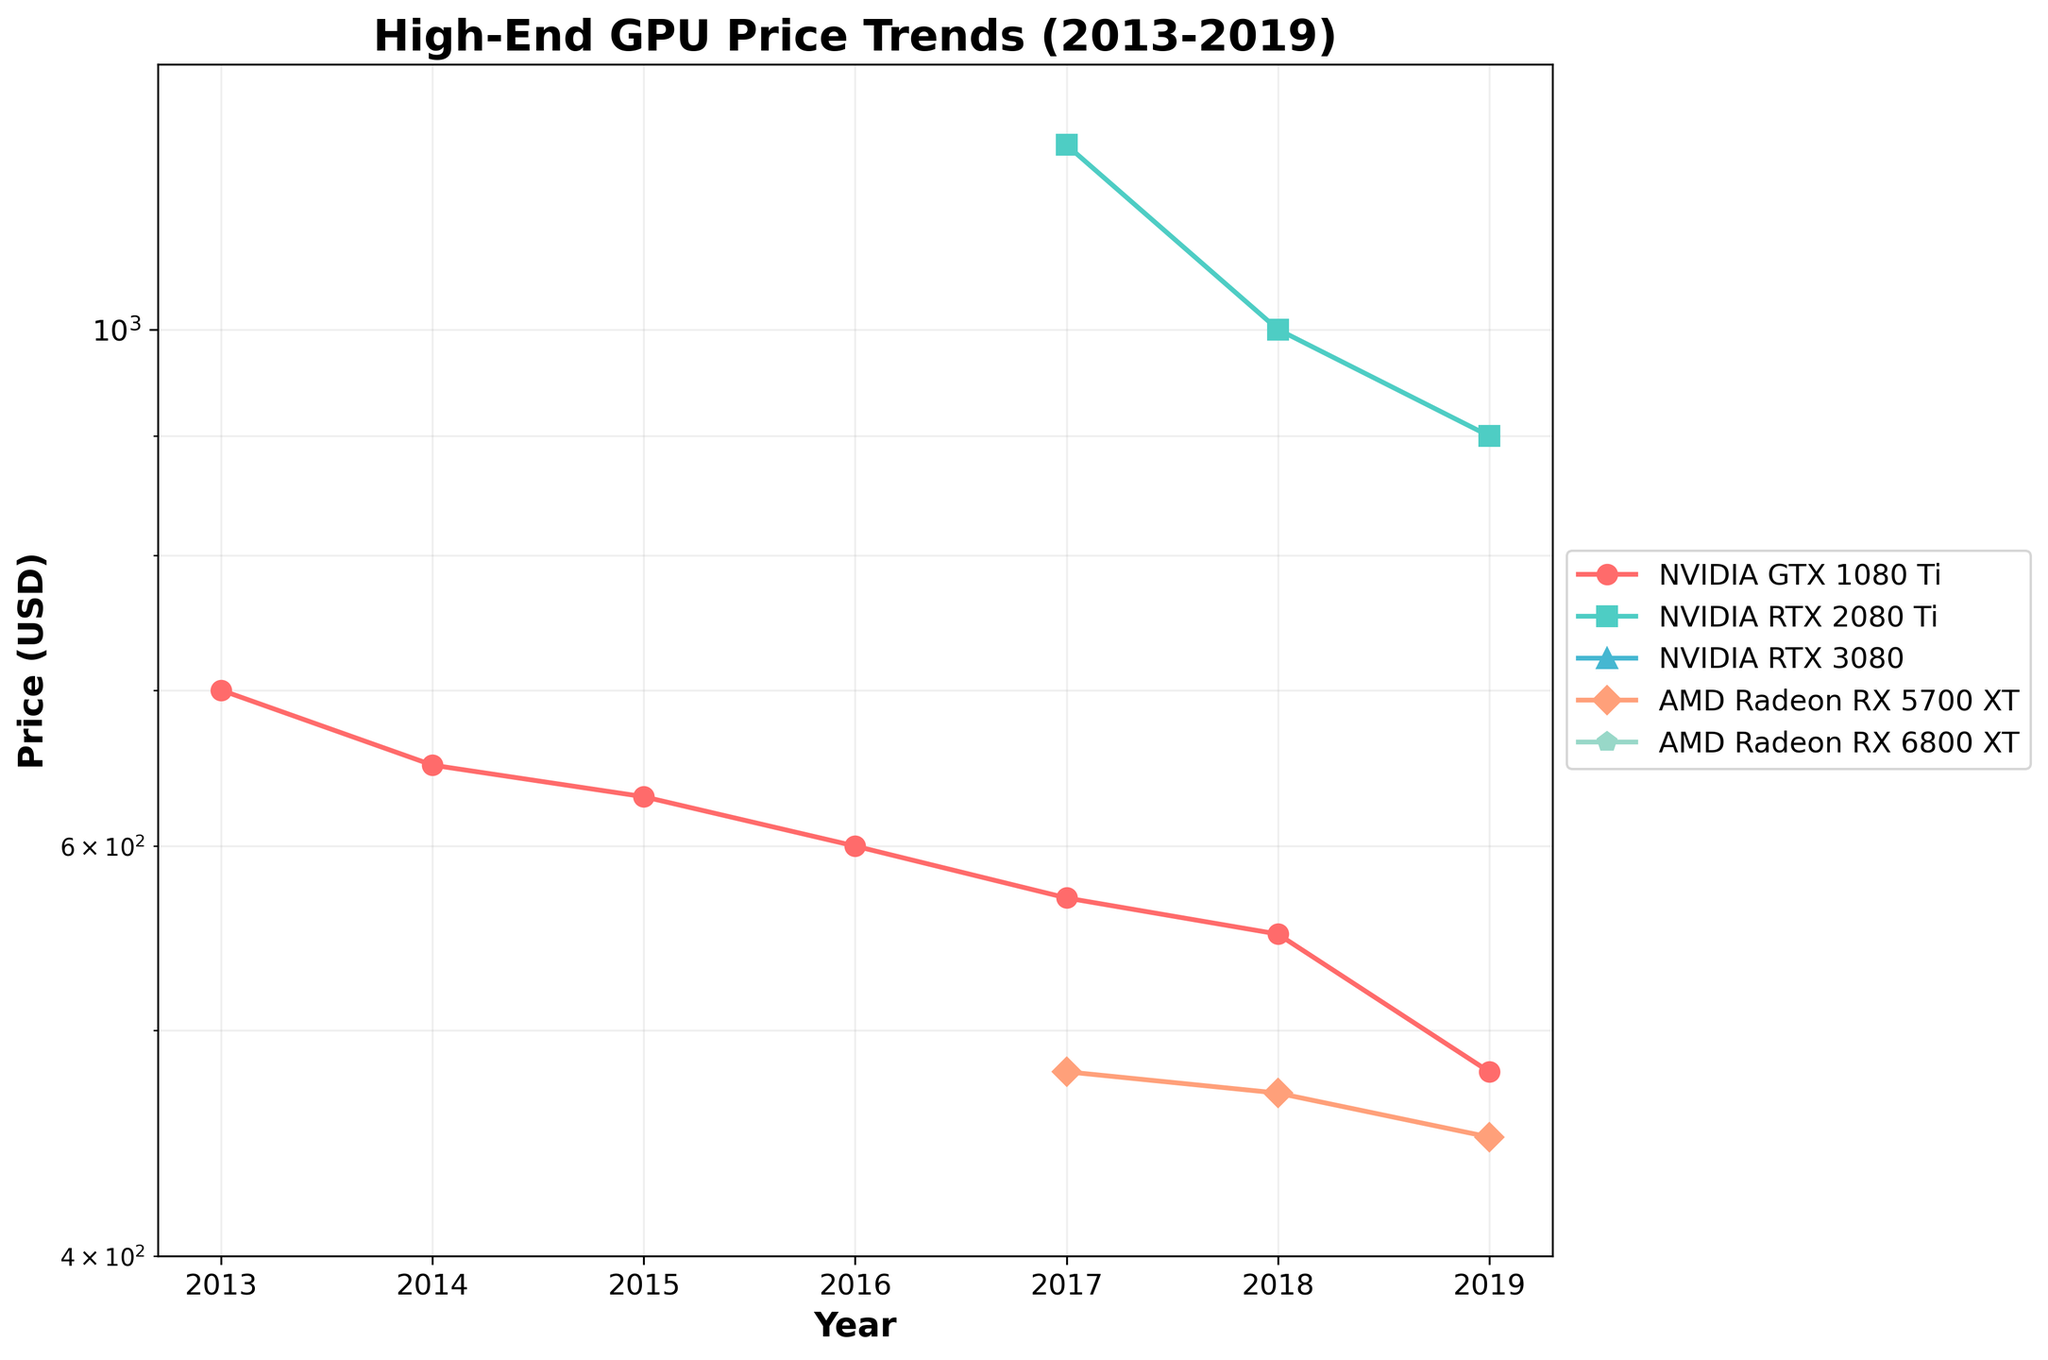When does the NVIDIA GTX 1080 Ti reach its lowest price? The NVIDIA GTX 1080 Ti shows a downward trend in price over the years. By inspecting the graph, the lowest price appears in 2019.
Answer: 2019 What is the approximate trend in price for the AMD Radeon RX 5700 XT from 2017 to 2019? By observing the line representing the AMD Radeon RX 5700 XT, the price decreases from 479.99 USD in 2017 to 449.99 USD in 2019.
Answer: Decreasing Among the GPUs listed, which one has the highest price point in 2017? Check the 2017 data points and find the highest price. The NVIDIA RTX 2080 Ti has a price of 1199.99 USD, which is the highest.
Answer: NVIDIA RTX 2080 Ti How does the trend of NVIDIA RTX 2080 Ti compare to AMD Radeon RX 5700 XT between 2018 and 2019? The NVIDIA RTX 2080 Ti shows a decreasing trend from 999.99 USD to 899.99 USD, while the AMD Radeon RX 5700 XT also decreases from 469.99 USD to 449.99 USD. Both show a decreasing trend.
Answer: Both decrease What's the range of prices for the NVIDIA GTX 1080 Ti over the years? Identify the highest and lowest prices. Highest is 699.99 USD (2013), and lowest is 479.99 USD (2019). Compute the range: 699.99 - 479.99 = 220 USD.
Answer: 220 USD In which year does the AMD Radeon RX 6800 XT appear in the data? Trace the line for AMD Radeon RX 6800 XT to find the first year with a data point. In this particular dataset, it doesn't appear at all.
Answer: Never appeared Calculate the average price of the NVIDIA GTX 1080 Ti between 2013 and 2019. Sum the prices of NVIDIA GTX 1080 Ti for each year available: (699.99 + 649.99 + 629.99 + 599.99 + 569.99 + 549.99 + 479.99) = 4179.93 USD. Divide by the number of years (7): 4179.93/7 ≈ 597.13 USD.
Answer: 597.13 USD Which GPU had the most significant price drop between any two consecutive years? Examine the decreases between consecutive years for each GPU. The NVIDIA RTX 2080 Ti dropped from 999.99 USD in 2018 to 899.99 USD in 2019, which is a 100 USD drop. No other GPU had a larger drop.
Answer: NVIDIA RTX 2080 Ti Does any GPU have a constant price over the years? Validate any line that remains flat across the years. All GPU lines, including NVIDIA GTX 1080 Ti, exhibit changing prices, indicating no constant price.
Answer: No 